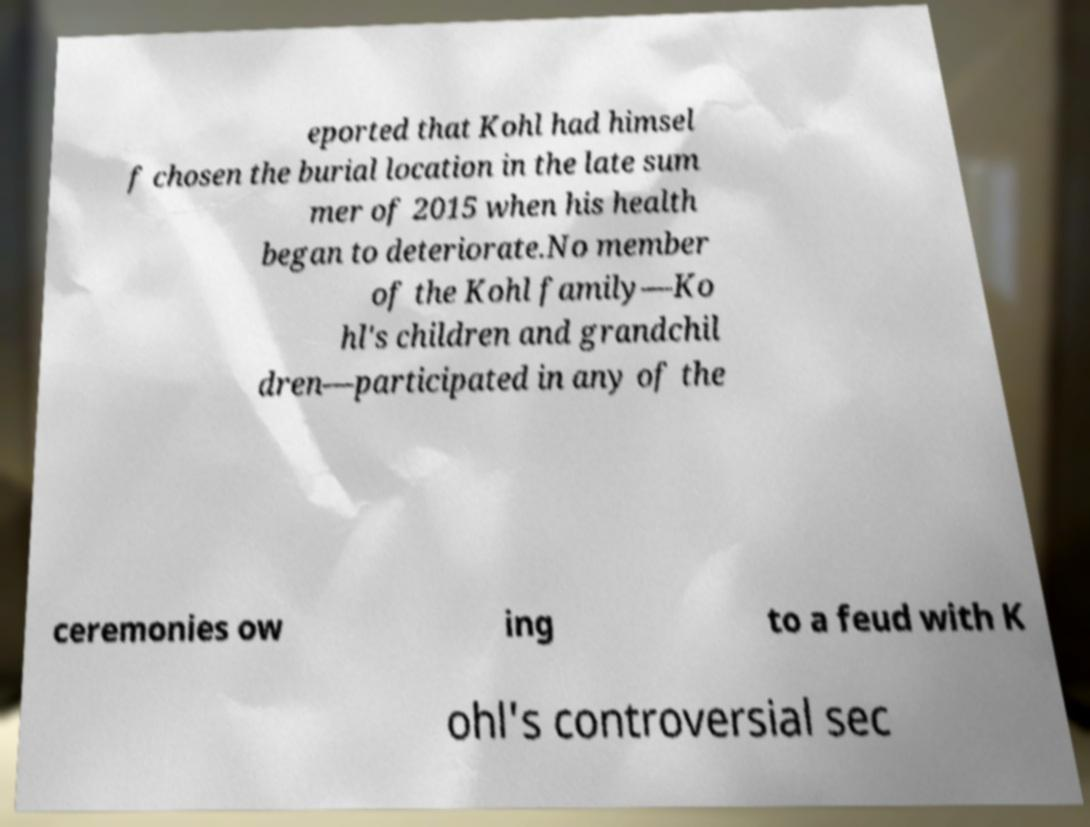For documentation purposes, I need the text within this image transcribed. Could you provide that? eported that Kohl had himsel f chosen the burial location in the late sum mer of 2015 when his health began to deteriorate.No member of the Kohl family—Ko hl's children and grandchil dren—participated in any of the ceremonies ow ing to a feud with K ohl's controversial sec 